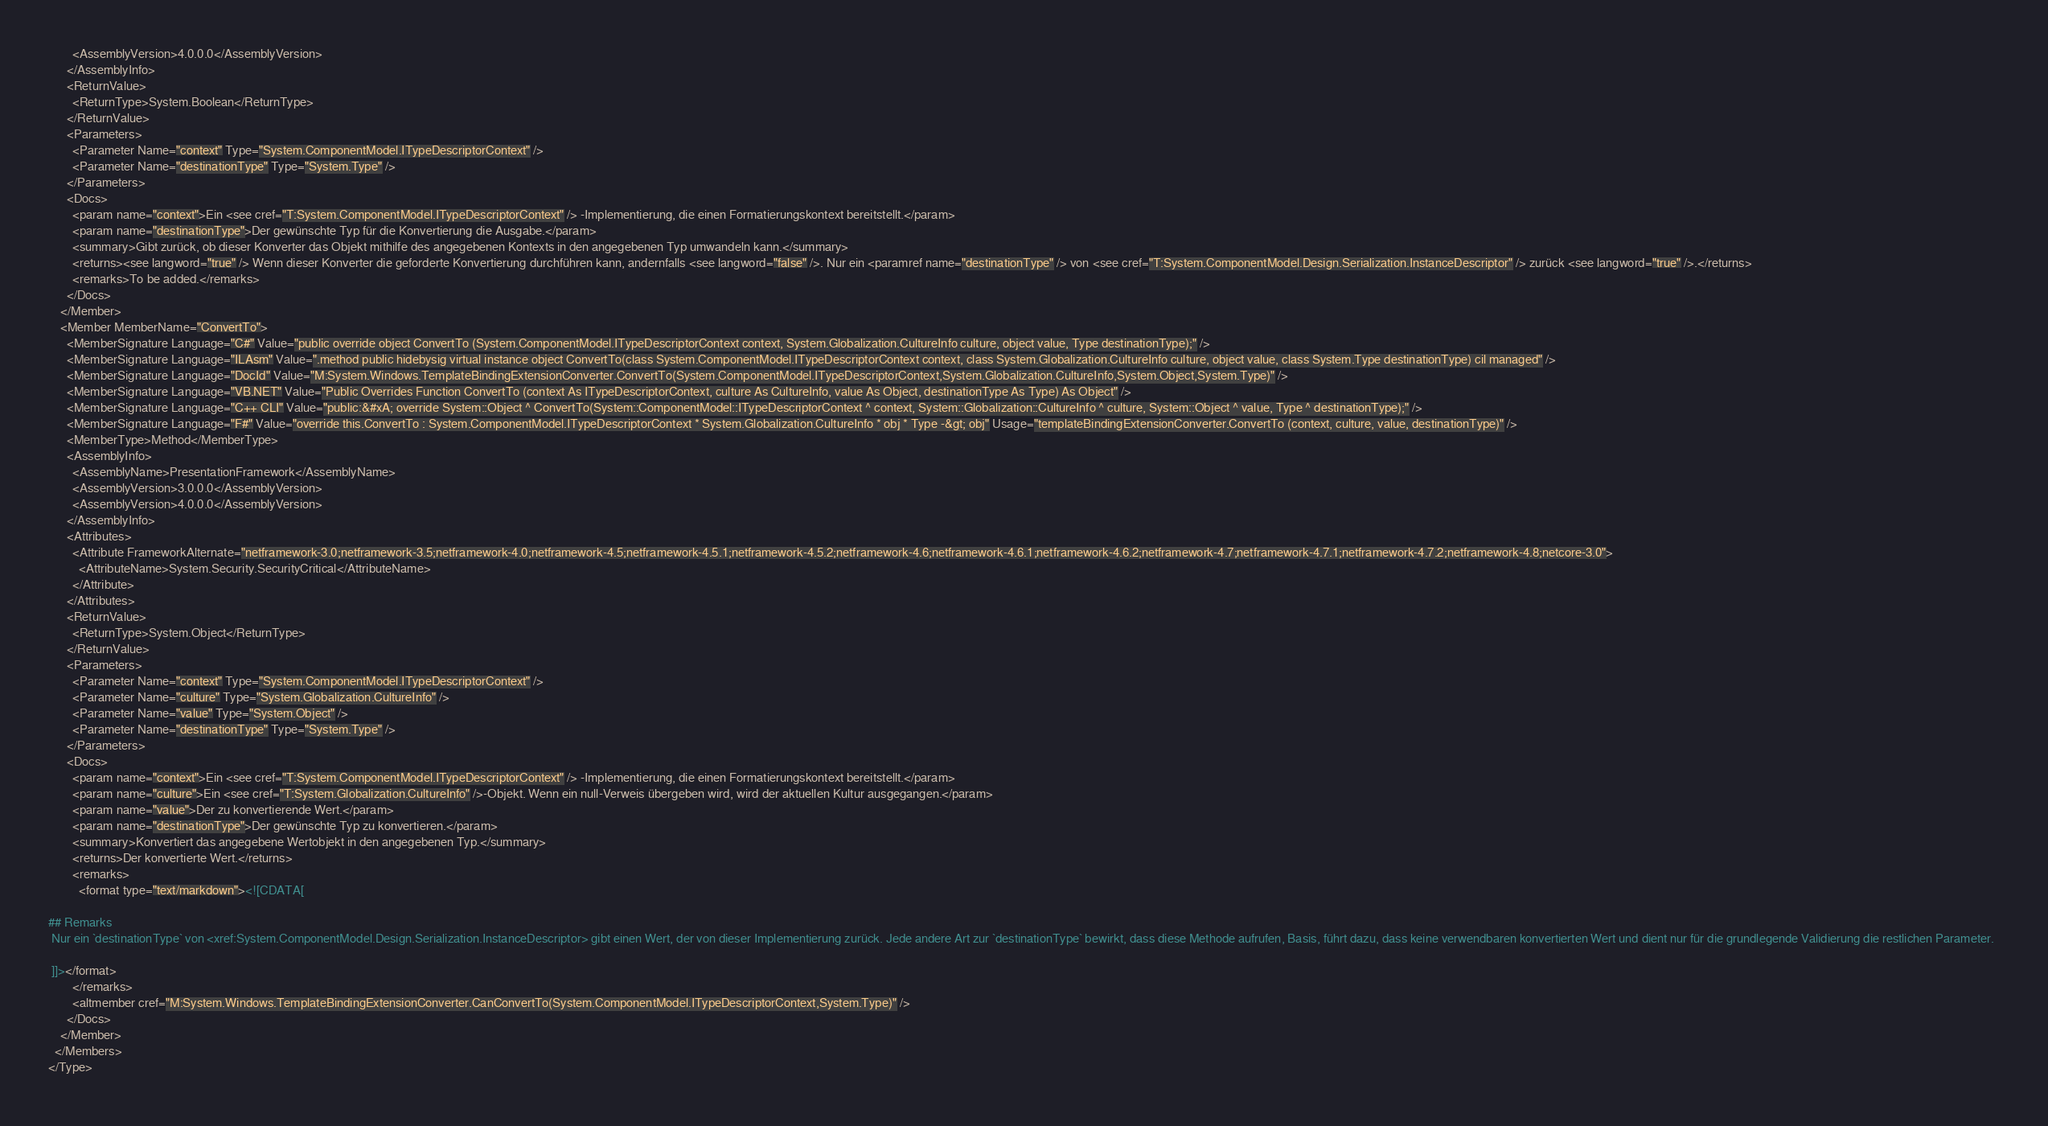Convert code to text. <code><loc_0><loc_0><loc_500><loc_500><_XML_>        <AssemblyVersion>4.0.0.0</AssemblyVersion>
      </AssemblyInfo>
      <ReturnValue>
        <ReturnType>System.Boolean</ReturnType>
      </ReturnValue>
      <Parameters>
        <Parameter Name="context" Type="System.ComponentModel.ITypeDescriptorContext" />
        <Parameter Name="destinationType" Type="System.Type" />
      </Parameters>
      <Docs>
        <param name="context">Ein <see cref="T:System.ComponentModel.ITypeDescriptorContext" /> -Implementierung, die einen Formatierungskontext bereitstellt.</param>
        <param name="destinationType">Der gewünschte Typ für die Konvertierung die Ausgabe.</param>
        <summary>Gibt zurück, ob dieser Konverter das Objekt mithilfe des angegebenen Kontexts in den angegebenen Typ umwandeln kann.</summary>
        <returns><see langword="true" /> Wenn dieser Konverter die geforderte Konvertierung durchführen kann, andernfalls <see langword="false" />. Nur ein <paramref name="destinationType" /> von <see cref="T:System.ComponentModel.Design.Serialization.InstanceDescriptor" /> zurück <see langword="true" />.</returns>
        <remarks>To be added.</remarks>
      </Docs>
    </Member>
    <Member MemberName="ConvertTo">
      <MemberSignature Language="C#" Value="public override object ConvertTo (System.ComponentModel.ITypeDescriptorContext context, System.Globalization.CultureInfo culture, object value, Type destinationType);" />
      <MemberSignature Language="ILAsm" Value=".method public hidebysig virtual instance object ConvertTo(class System.ComponentModel.ITypeDescriptorContext context, class System.Globalization.CultureInfo culture, object value, class System.Type destinationType) cil managed" />
      <MemberSignature Language="DocId" Value="M:System.Windows.TemplateBindingExtensionConverter.ConvertTo(System.ComponentModel.ITypeDescriptorContext,System.Globalization.CultureInfo,System.Object,System.Type)" />
      <MemberSignature Language="VB.NET" Value="Public Overrides Function ConvertTo (context As ITypeDescriptorContext, culture As CultureInfo, value As Object, destinationType As Type) As Object" />
      <MemberSignature Language="C++ CLI" Value="public:&#xA; override System::Object ^ ConvertTo(System::ComponentModel::ITypeDescriptorContext ^ context, System::Globalization::CultureInfo ^ culture, System::Object ^ value, Type ^ destinationType);" />
      <MemberSignature Language="F#" Value="override this.ConvertTo : System.ComponentModel.ITypeDescriptorContext * System.Globalization.CultureInfo * obj * Type -&gt; obj" Usage="templateBindingExtensionConverter.ConvertTo (context, culture, value, destinationType)" />
      <MemberType>Method</MemberType>
      <AssemblyInfo>
        <AssemblyName>PresentationFramework</AssemblyName>
        <AssemblyVersion>3.0.0.0</AssemblyVersion>
        <AssemblyVersion>4.0.0.0</AssemblyVersion>
      </AssemblyInfo>
      <Attributes>
        <Attribute FrameworkAlternate="netframework-3.0;netframework-3.5;netframework-4.0;netframework-4.5;netframework-4.5.1;netframework-4.5.2;netframework-4.6;netframework-4.6.1;netframework-4.6.2;netframework-4.7;netframework-4.7.1;netframework-4.7.2;netframework-4.8;netcore-3.0">
          <AttributeName>System.Security.SecurityCritical</AttributeName>
        </Attribute>
      </Attributes>
      <ReturnValue>
        <ReturnType>System.Object</ReturnType>
      </ReturnValue>
      <Parameters>
        <Parameter Name="context" Type="System.ComponentModel.ITypeDescriptorContext" />
        <Parameter Name="culture" Type="System.Globalization.CultureInfo" />
        <Parameter Name="value" Type="System.Object" />
        <Parameter Name="destinationType" Type="System.Type" />
      </Parameters>
      <Docs>
        <param name="context">Ein <see cref="T:System.ComponentModel.ITypeDescriptorContext" /> -Implementierung, die einen Formatierungskontext bereitstellt.</param>
        <param name="culture">Ein <see cref="T:System.Globalization.CultureInfo" />-Objekt. Wenn ein null-Verweis übergeben wird, wird der aktuellen Kultur ausgegangen.</param>
        <param name="value">Der zu konvertierende Wert.</param>
        <param name="destinationType">Der gewünschte Typ zu konvertieren.</param>
        <summary>Konvertiert das angegebene Wertobjekt in den angegebenen Typ.</summary>
        <returns>Der konvertierte Wert.</returns>
        <remarks>
          <format type="text/markdown"><![CDATA[  
  
## Remarks  
 Nur ein `destinationType` von <xref:System.ComponentModel.Design.Serialization.InstanceDescriptor> gibt einen Wert, der von dieser Implementierung zurück. Jede andere Art zur `destinationType` bewirkt, dass diese Methode aufrufen, Basis, führt dazu, dass keine verwendbaren konvertierten Wert und dient nur für die grundlegende Validierung die restlichen Parameter.  
  
 ]]></format>
        </remarks>
        <altmember cref="M:System.Windows.TemplateBindingExtensionConverter.CanConvertTo(System.ComponentModel.ITypeDescriptorContext,System.Type)" />
      </Docs>
    </Member>
  </Members>
</Type></code> 